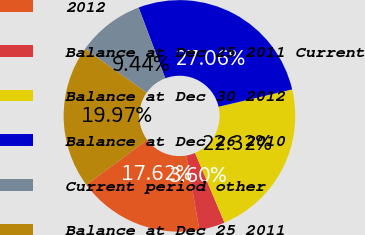Convert chart. <chart><loc_0><loc_0><loc_500><loc_500><pie_chart><fcel>2012<fcel>Balance at Dec 25 2011 Current<fcel>Balance at Dec 30 2012<fcel>Balance at Dec 26 2010<fcel>Current period other<fcel>Balance at Dec 25 2011<nl><fcel>17.62%<fcel>3.6%<fcel>22.32%<fcel>27.06%<fcel>9.44%<fcel>19.97%<nl></chart> 